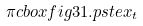<formula> <loc_0><loc_0><loc_500><loc_500>\pi c b o x { f i g 3 1 . p s t e x _ { t } }</formula> 